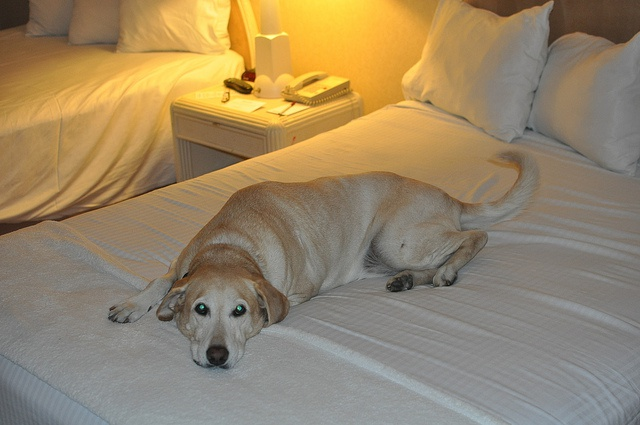Describe the objects in this image and their specific colors. I can see bed in black and gray tones, dog in black and gray tones, bed in black, tan, gold, and olive tones, and remote in black, olive, and maroon tones in this image. 